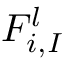Convert formula to latex. <formula><loc_0><loc_0><loc_500><loc_500>F _ { i , I } ^ { l }</formula> 